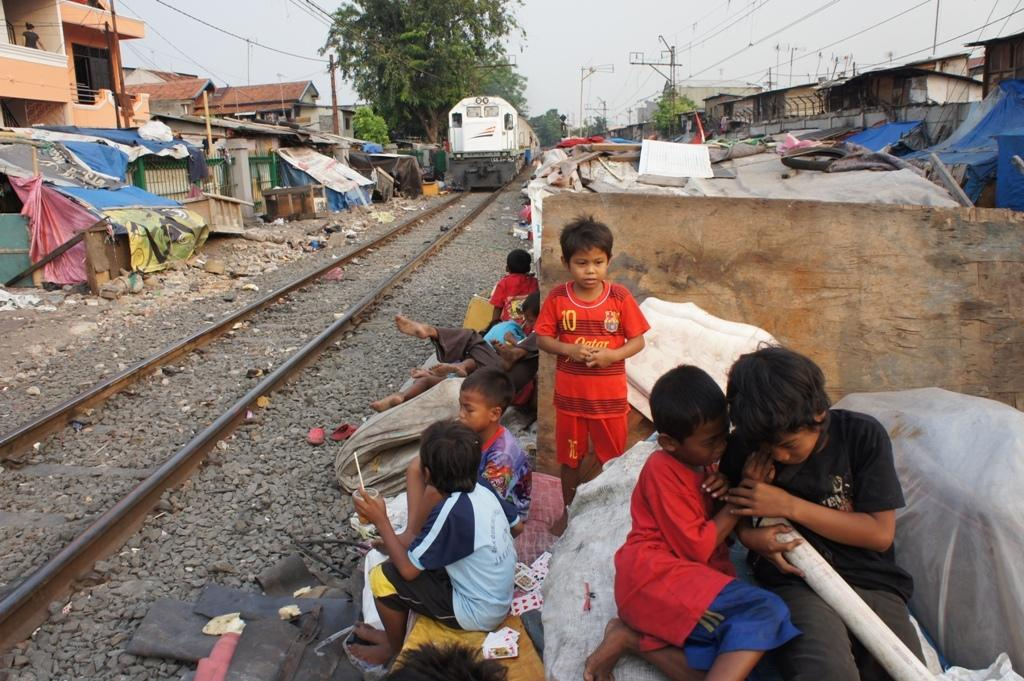What type of structures can be seen in the image? There are many houses in the image. What else can be seen in the image besides houses? There are children in the image. What are some of the children doing? Some children are playing, and some are sitting. What type of vegetation is present in the image? There are many trees in the image. Where is the hose being used in the image? There is no hose present in the image. What type of fruit is being peeled by the children in the image? There is no fruit, such as a banana, being peeled by the children in the image. 